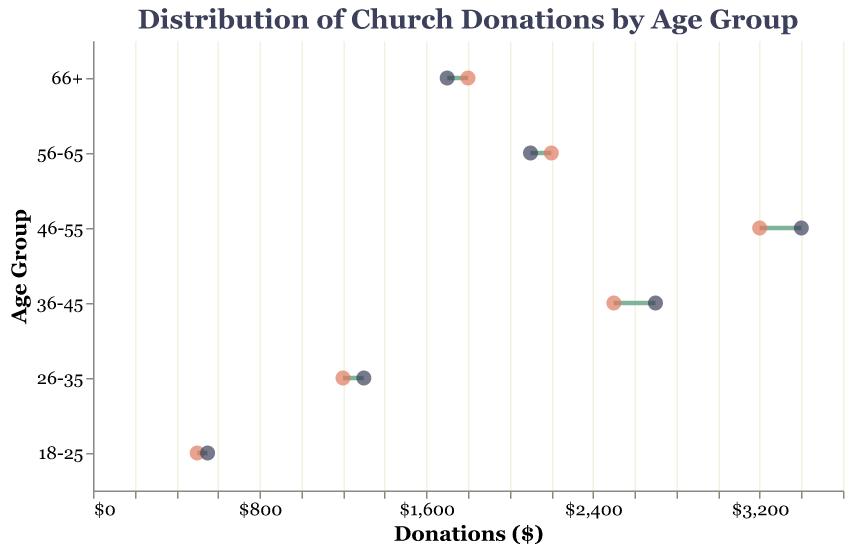What's the title of the plot? The title of the plot is found at the top and is labeled "Distribution of Church Donations by Age Group".
Answer: Distribution of Church Donations by Age Group How many age groups are represented in the plot? By looking at the y-axis, we can see six distinct age groups listed.
Answer: Six Which age group had the largest increase in donations from 2022 to 2023? The difference in donations for each group can be calculated. For 18-25, it's 50; for 26-35, it's 100; for 36-45, it's 200; for 46-55, it's 200; for 56-65, it's -100; and for 66+, it's -100. The largest positive increase is 200, seen in both the 36-45 and 46-55 groups.
Answer: 36-45 and 46-55 What are the colors used to represent the data points for 2022 and 2023 donations? The points for 2022 donations are filled with a reddish color, and the points for 2023 donations are filled with a dark grayish color.
Answer: Reddish for 2022, Dark Grayish for 2023 What's the total amount of donations in 2023 across all age groups? Summing the donations in 2023 for all age groups: 550 + 1300 + 2700 + 3400 + 2100 + 1700. This gives 550 + 1300 + 2700 + 3400 + 2100 + 1700 = 11750.
Answer: 11750 Which age group saw a decrease in donations from 2022 to 2023? Comparing the donations for each age group between the two years, the 56-65 and 66+ age groups saw a decrease, with donations going from 2200 to 2100 for 56-65, and from 1800 to 1700 for 66+.
Answer: 56-65 and 66+ What is the average donation in 2022 across all age groups? Summing the donations for all groups in 2022 gives: 500 + 1200 + 2500 + 3200 + 2200 + 1800 = 11400. Dividing by the number of groups (6), the average is 11400/6.
Answer: 1900 Which age group had the highest donation amount in 2023, and what was the amount? The highest donation amount in 2023 can be seen by looking at the x-axis values for each age group. The 46-55 age group had the highest with 3400.
Answer: 46-55, 3400 What's the difference in total donations between 2023 and 2022? Total donations for 2023 is 11750 and for 2022 is 11400. The difference is 11750 - 11400.
Answer: 350 